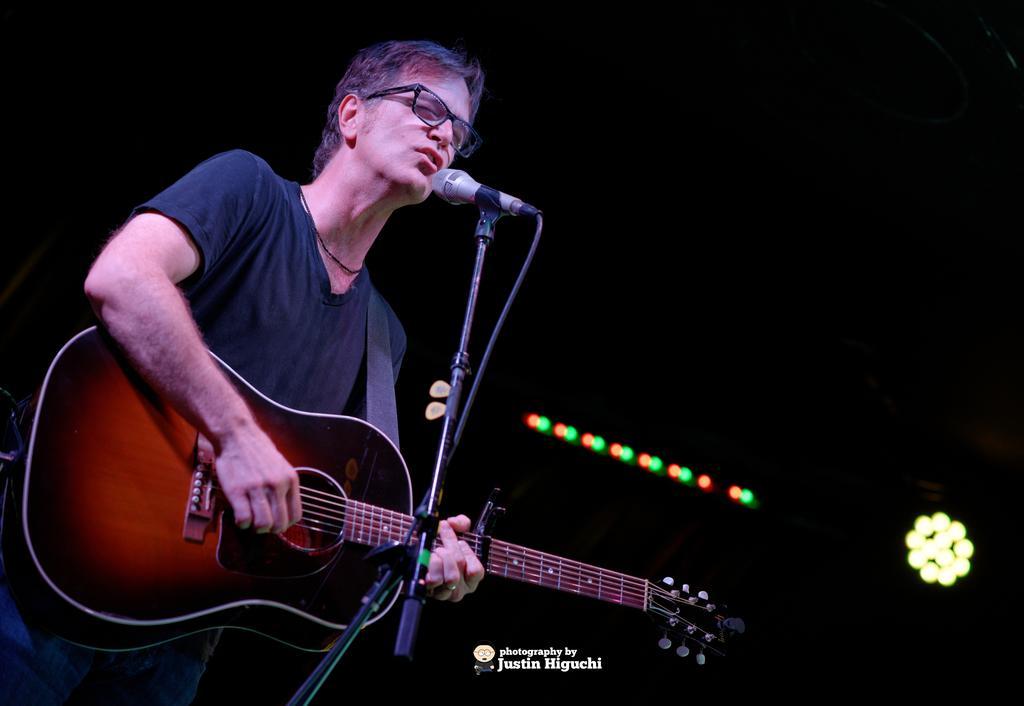Please provide a concise description of this image. In this picture there is a guy singing on mic holding a guitar playing it and the background there are some lights. 